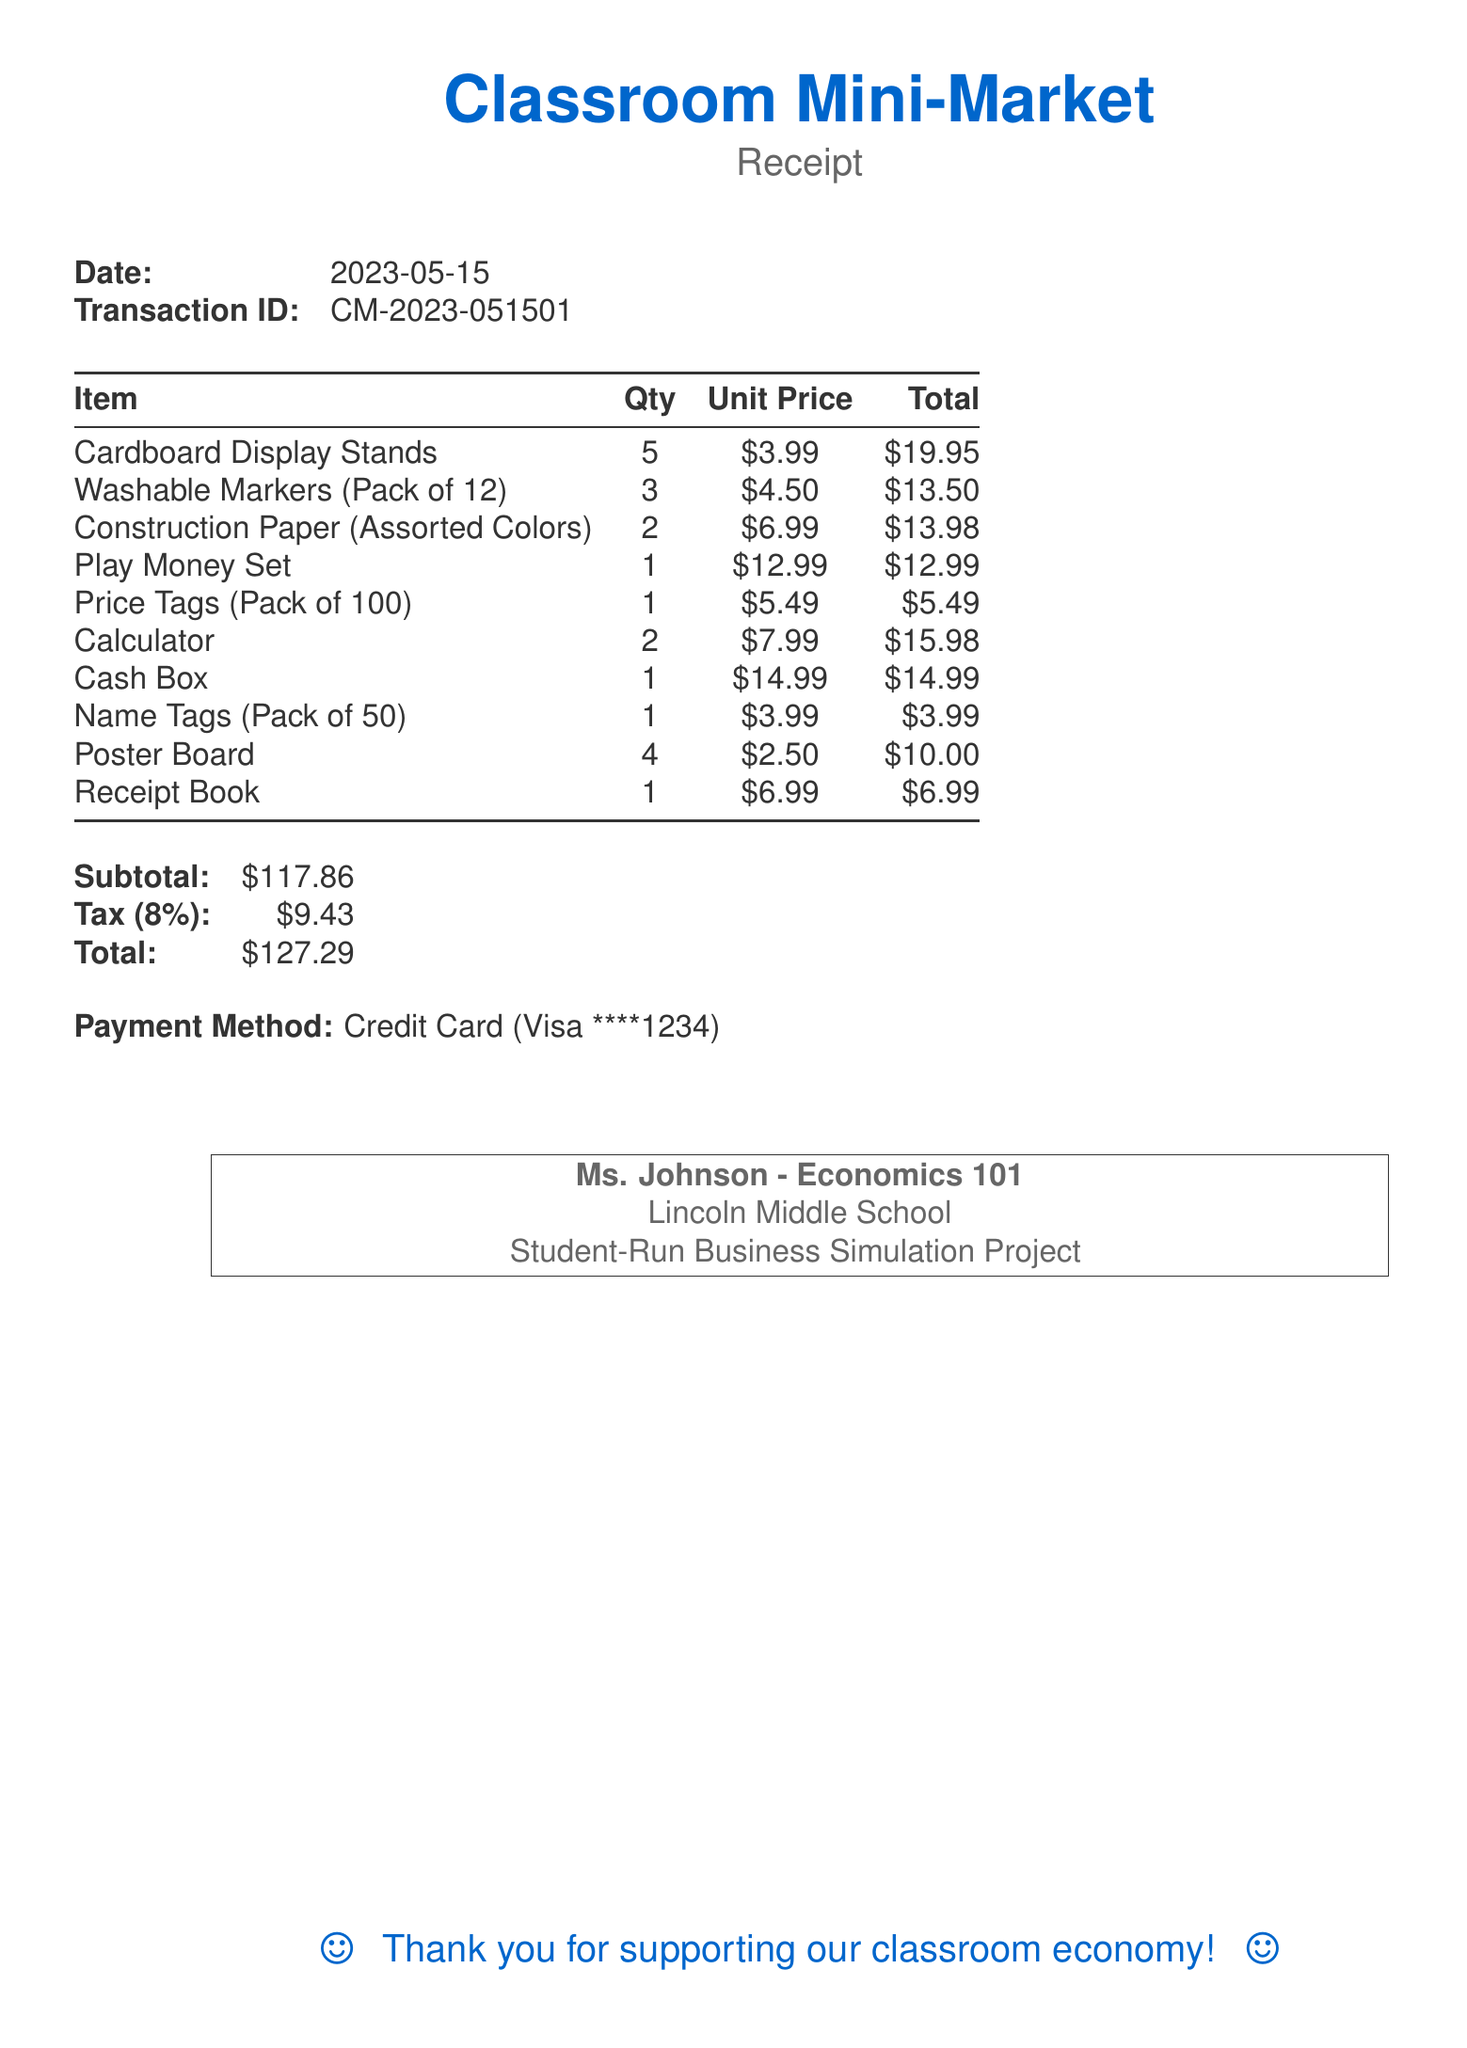what is the date of the receipt? The date of the receipt is clearly stated in the document under the receipt header.
Answer: 2023-05-15 how many Cardboard Display Stands were purchased? The quantity of Cardboard Display Stands is mentioned in the items section of the document.
Answer: 5 what is the unit price of Washable Markers? The unit price of Washable Markers is provided alongside each item in the list.
Answer: $4.50 what is the subtotal amount? The subtotal is summarized at the end of the receipt in the totals section.
Answer: $117.86 who is the teacher for this project? The teacher's name appears in the footer section of the document.
Answer: Ms. Johnson what is the tax rate listed on the receipt? The tax rate is specified in the totals section of the document along with the tax amount.
Answer: 8% how much did the Cash Box cost? The cost of the Cash Box is detailed in the items list of the document.
Answer: $14.99 what payment method was used? The payment method is stated in the payment section at the end of the receipt.
Answer: Credit Card how many items are listed in total? The total number of different items can be counted from the items section.
Answer: 10 